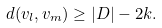Convert formula to latex. <formula><loc_0><loc_0><loc_500><loc_500>d ( v _ { l } , v _ { m } ) \geq | D | - 2 k .</formula> 